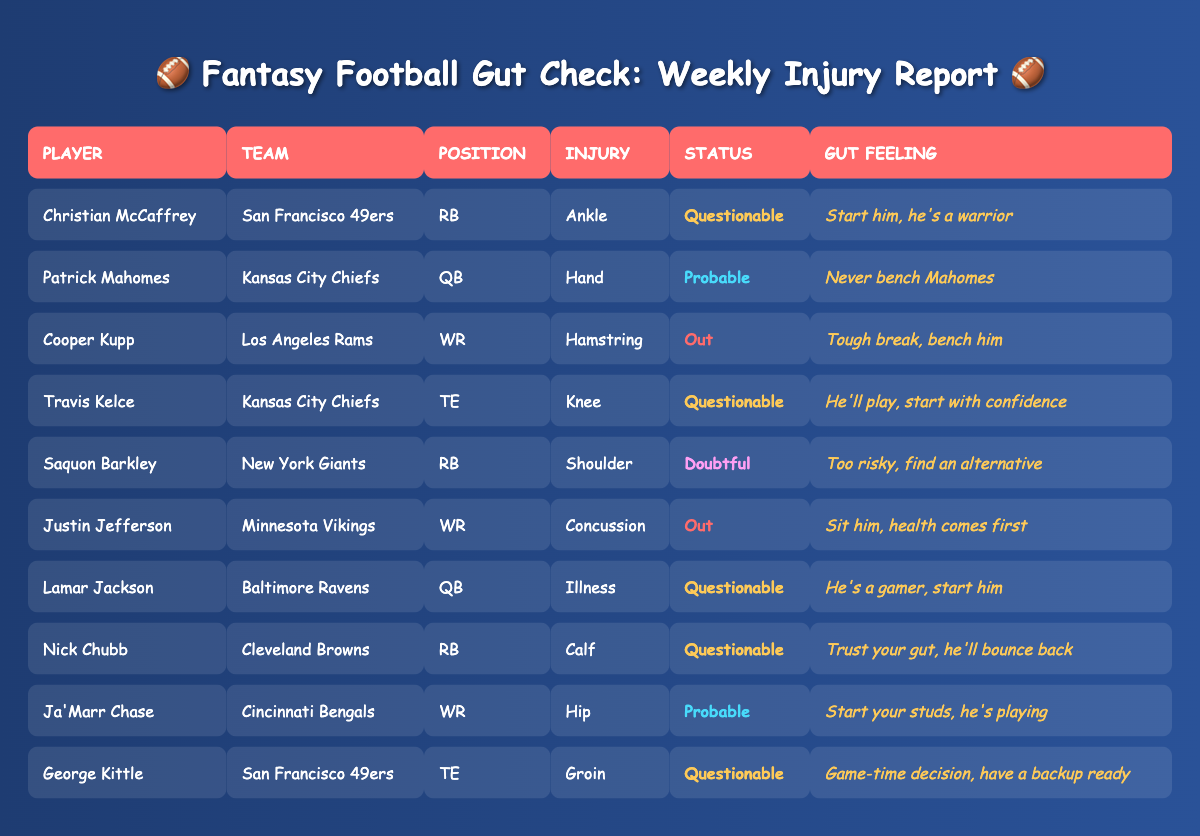What is the status of Christian McCaffrey? The table displays that Christian McCaffrey's status is "Questionable," as indicated in the Status column next to his name.
Answer: Questionable Which player is out with a hamstring injury? The table shows that Cooper Kupp has a hamstring injury and is listed as "Out," as noted in the Injury and Status columns for him.
Answer: Cooper Kupp How many players are listed as "Probable"? By counting the entries in the Status column, there are three players marked as "Probable": Patrick Mahomes, Ja'Marr Chase, and Travis Kelce.
Answer: 3 Is Nick Chubb active this week? Nick Chubb's status is listed as "Questionable," which implies that he may or may not play this week, but he is not definitively inactive. Therefore, the answer is no.
Answer: No Which players are considered safe to start according to the gut feeling provided? According to the Gut Feeling column, both Patrick Mahomes and Ja'Marr Chase are considered safe to start due to their strong gut feelings. The status of Travis Kelce also suggests he can be started confidently.
Answer: Patrick Mahomes, Ja'Marr Chase, Travis Kelce What is the total number of players reported as "Out"? There are two players reported as "Out" in the table: Cooper Kupp and Justin Jefferson, from which we conclude the total number of "Out" players is 2.
Answer: 2 If you had to avoid one running back this week, who would it be based on their status? Based on the table, Saquon Barkley is listed as "Doubtful," which indicates that he is the running back to avoid this week.
Answer: Saquon Barkley Which player has an ankle injury? The table shows that Christian McCaffrey has an ankle injury, as reflected in the Injury column next to his name.
Answer: Christian McCaffrey Who has a calf injury and what is their status? Nick Chubb has a calf injury and is labeled as "Questionable" in the Status column. This information is directly taken from the respective columns of the table.
Answer: Nick Chubb, Questionable 